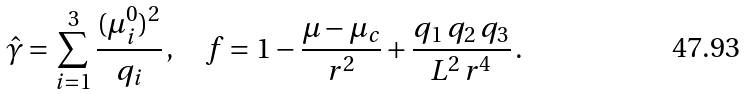<formula> <loc_0><loc_0><loc_500><loc_500>\hat { \gamma } = \sum _ { i = 1 } ^ { 3 } \frac { ( \mu _ { i } ^ { 0 } ) ^ { 2 } } { q _ { i } } \, , \quad f = 1 - \frac { \mu - \mu _ { c } } { r ^ { 2 } } + \frac { q _ { 1 } \, q _ { 2 } \, q _ { 3 } } { L ^ { 2 } \, r ^ { 4 } } \, .</formula> 